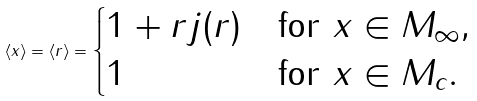<formula> <loc_0><loc_0><loc_500><loc_500>\langle x \rangle = \langle r \rangle = \begin{cases} 1 + r j ( r ) & \text {for} \ x \in M _ { \infty } , \\ 1 & \text {for} \ x \in M _ { c } . \end{cases}</formula> 